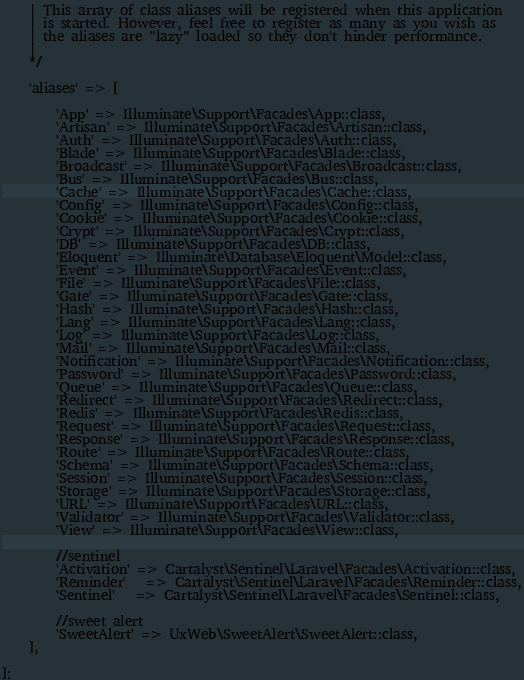Convert code to text. <code><loc_0><loc_0><loc_500><loc_500><_PHP_>    | This array of class aliases will be registered when this application
    | is started. However, feel free to register as many as you wish as
    | the aliases are "lazy" loaded so they don't hinder performance.
    |
    */

    'aliases' => [

        'App' => Illuminate\Support\Facades\App::class,
        'Artisan' => Illuminate\Support\Facades\Artisan::class,
        'Auth' => Illuminate\Support\Facades\Auth::class,
        'Blade' => Illuminate\Support\Facades\Blade::class,
        'Broadcast' => Illuminate\Support\Facades\Broadcast::class,
        'Bus' => Illuminate\Support\Facades\Bus::class,
        'Cache' => Illuminate\Support\Facades\Cache::class,
        'Config' => Illuminate\Support\Facades\Config::class,
        'Cookie' => Illuminate\Support\Facades\Cookie::class,
        'Crypt' => Illuminate\Support\Facades\Crypt::class,
        'DB' => Illuminate\Support\Facades\DB::class,
        'Eloquent' => Illuminate\Database\Eloquent\Model::class,
        'Event' => Illuminate\Support\Facades\Event::class,
        'File' => Illuminate\Support\Facades\File::class,
        'Gate' => Illuminate\Support\Facades\Gate::class,
        'Hash' => Illuminate\Support\Facades\Hash::class,
        'Lang' => Illuminate\Support\Facades\Lang::class,
        'Log' => Illuminate\Support\Facades\Log::class,
        'Mail' => Illuminate\Support\Facades\Mail::class,
        'Notification' => Illuminate\Support\Facades\Notification::class,
        'Password' => Illuminate\Support\Facades\Password::class,
        'Queue' => Illuminate\Support\Facades\Queue::class,
        'Redirect' => Illuminate\Support\Facades\Redirect::class,
        'Redis' => Illuminate\Support\Facades\Redis::class,
        'Request' => Illuminate\Support\Facades\Request::class,
        'Response' => Illuminate\Support\Facades\Response::class,
        'Route' => Illuminate\Support\Facades\Route::class,
        'Schema' => Illuminate\Support\Facades\Schema::class,
        'Session' => Illuminate\Support\Facades\Session::class,
        'Storage' => Illuminate\Support\Facades\Storage::class,
        'URL' => Illuminate\Support\Facades\URL::class,
        'Validator' => Illuminate\Support\Facades\Validator::class,
        'View' => Illuminate\Support\Facades\View::class,

        //sentinel
        'Activation' => Cartalyst\Sentinel\Laravel\Facades\Activation::class,
        'Reminder'   => Cartalyst\Sentinel\Laravel\Facades\Reminder::class,
        'Sentinel'   => Cartalyst\Sentinel\Laravel\Facades\Sentinel::class,

        //sweet alert
        'SweetAlert' => UxWeb\SweetAlert\SweetAlert::class,
    ],

];
</code> 